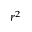<formula> <loc_0><loc_0><loc_500><loc_500>r ^ { 2 }</formula> 